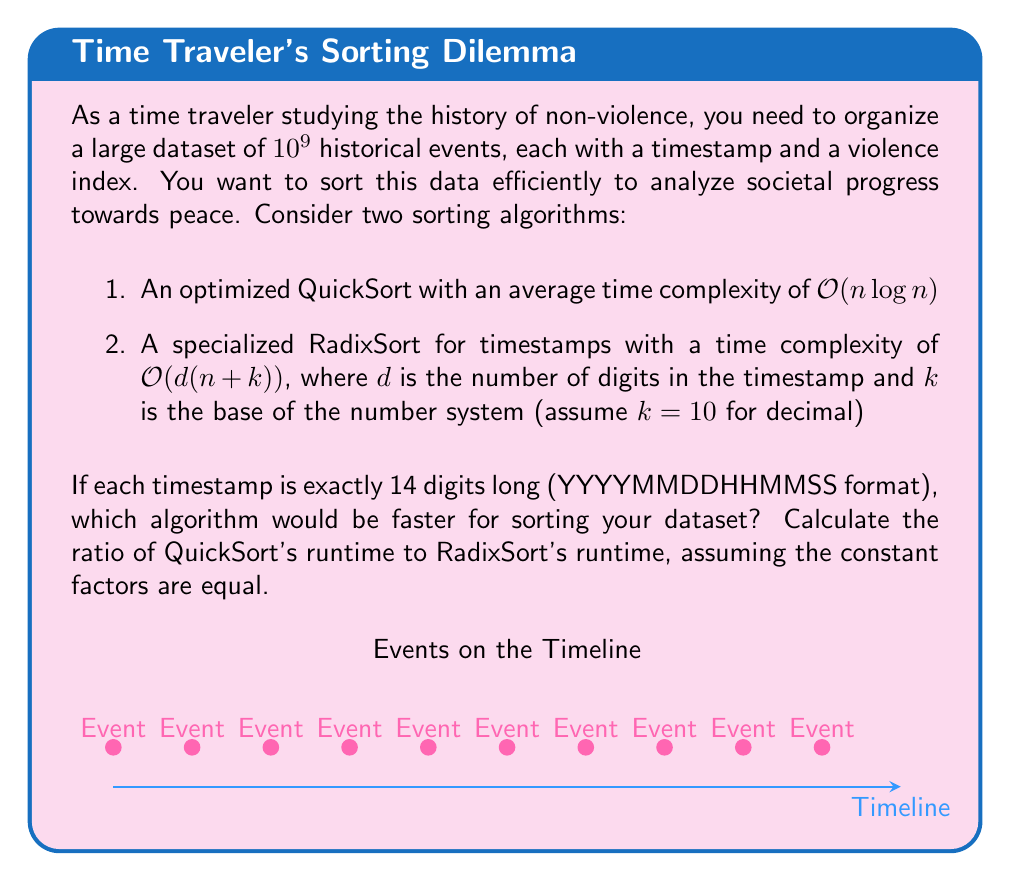Teach me how to tackle this problem. Let's approach this step-by-step:

1) First, let's define our variables:
   $n = 10^9$ (number of events)
   $d = 14$ (number of digits in timestamp)
   $k = 10$ (base of number system)

2) QuickSort time complexity:
   $T_{QuickSort} = c_1 \cdot n \log n$
   Where $c_1$ is some constant factor.

3) RadixSort time complexity:
   $T_{RadixSort} = c_2 \cdot d(n+k)$
   Where $c_2$ is some constant factor.

4) Assuming $c_1 = c_2 = c$ (equal constant factors), we can calculate the ratio:

   $$\frac{T_{QuickSort}}{T_{RadixSort}} = \frac{c \cdot n \log n}{c \cdot d(n+k)}$$

5) The $c$ cancels out:

   $$\frac{T_{QuickSort}}{T_{RadixSort}} = \frac{n \log n}{d(n+k)}$$

6) Now, let's substitute our values:

   $$\frac{T_{QuickSort}}{T_{RadixSort}} = \frac{10^9 \log 10^9}{14(10^9+10)}$$

7) Simplify:
   $\log 10^9 = 9 \log 10 \approx 20.72$
   $10^9 + 10 \approx 10^9$ (the 10 is negligible compared to $10^9$)

   $$\frac{T_{QuickSort}}{T_{RadixSort}} \approx \frac{10^9 \cdot 20.72}{14 \cdot 10^9} \approx 1.48$$

8) This means QuickSort would take approximately 1.48 times as long as RadixSort for this specific dataset and timestamp format.
Answer: RadixSort is faster; QuickSort/RadixSort runtime ratio ≈ 1.48 